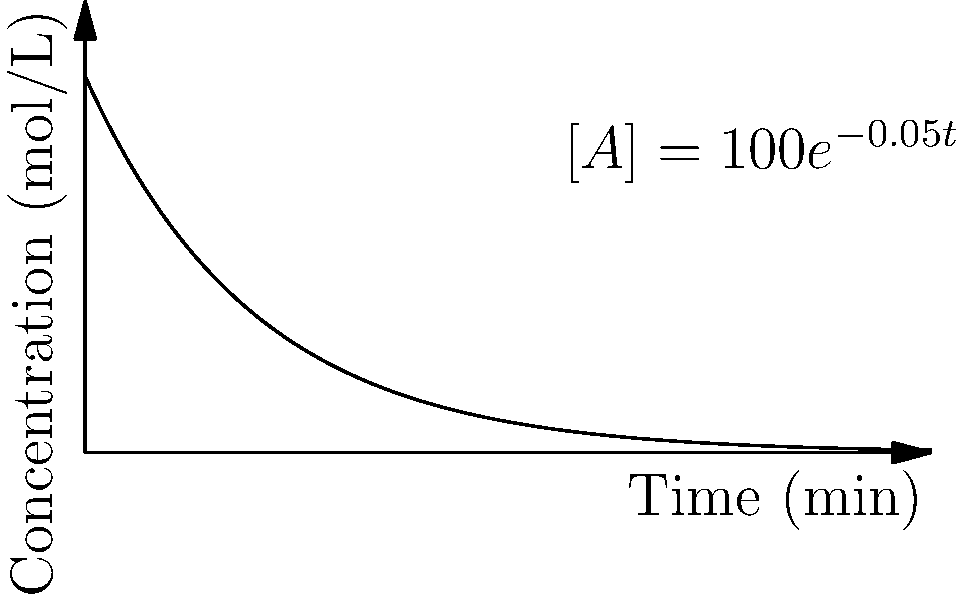The graph shows the concentration of reactant A over time for a first-order reaction. If the initial concentration of A is 100 mol/L, determine the rate constant (k) of the reaction. To determine the rate constant (k) for a first-order reaction, we can use the integrated rate law:

1. The integrated rate law for a first-order reaction is:
   $\ln[A] = -kt + \ln[A]_0$

2. From the graph, we can see that the equation of the line is:
   $[A] = 100e^{-0.05t}$

3. To match this with the integrated rate law, we need to take the natural log of both sides:
   $\ln[A] = \ln(100e^{-0.05t})$

4. Using the properties of logarithms:
   $\ln[A] = \ln(100) + \ln(e^{-0.05t})$
   $\ln[A] = 4.605 - 0.05t$

5. Comparing this to the integrated rate law form:
   $\ln[A] = -kt + \ln[A]_0$

6. We can see that:
   $k = 0.05$ min$^{-1}$
   $\ln[A]_0 = 4.605$ (which is indeed $\ln(100)$)

Therefore, the rate constant (k) of the reaction is 0.05 min$^{-1}$.
Answer: $k = 0.05$ min$^{-1}$ 